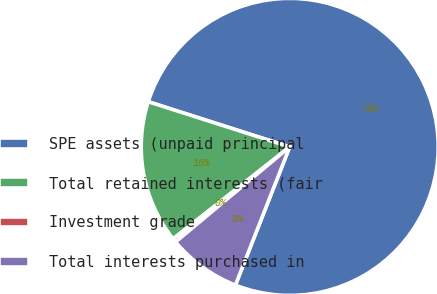Convert chart to OTSL. <chart><loc_0><loc_0><loc_500><loc_500><pie_chart><fcel>SPE assets (unpaid principal<fcel>Total retained interests (fair<fcel>Investment grade<fcel>Total interests purchased in<nl><fcel>76.04%<fcel>15.55%<fcel>0.42%<fcel>7.99%<nl></chart> 